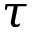Convert formula to latex. <formula><loc_0><loc_0><loc_500><loc_500>\tau</formula> 